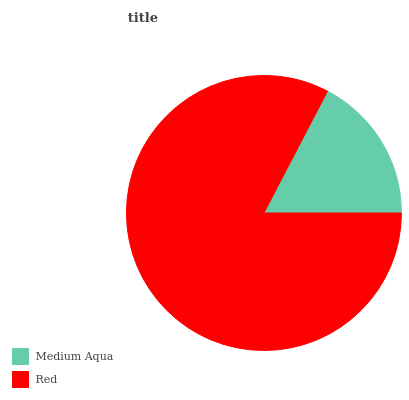Is Medium Aqua the minimum?
Answer yes or no. Yes. Is Red the maximum?
Answer yes or no. Yes. Is Red the minimum?
Answer yes or no. No. Is Red greater than Medium Aqua?
Answer yes or no. Yes. Is Medium Aqua less than Red?
Answer yes or no. Yes. Is Medium Aqua greater than Red?
Answer yes or no. No. Is Red less than Medium Aqua?
Answer yes or no. No. Is Red the high median?
Answer yes or no. Yes. Is Medium Aqua the low median?
Answer yes or no. Yes. Is Medium Aqua the high median?
Answer yes or no. No. Is Red the low median?
Answer yes or no. No. 